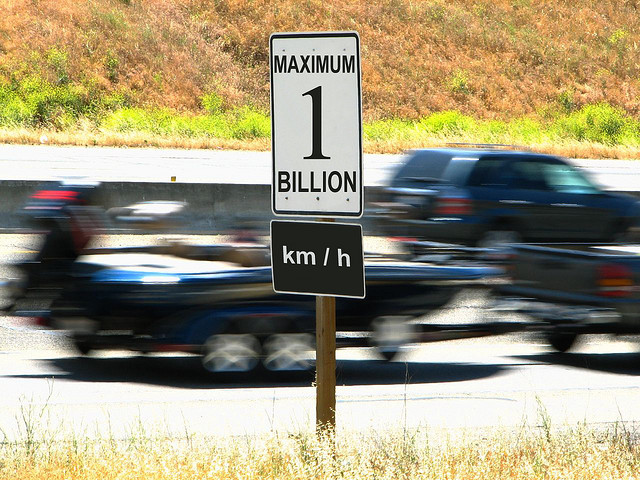How does the content of the road sign contrast with the environment in the photo? The road sign's content, stating 'MAXIMUM 1 BILLION km/h', starkly contrasts with the real-world setting where the natural laws of physics limit vehicle speeds to a tiny fraction of that number. This incongruity between the sign's message and the typical highway environment where realistic speed limits are expected can inspire reflections on the limitations of human achievements and the boundless realm of imagination. 